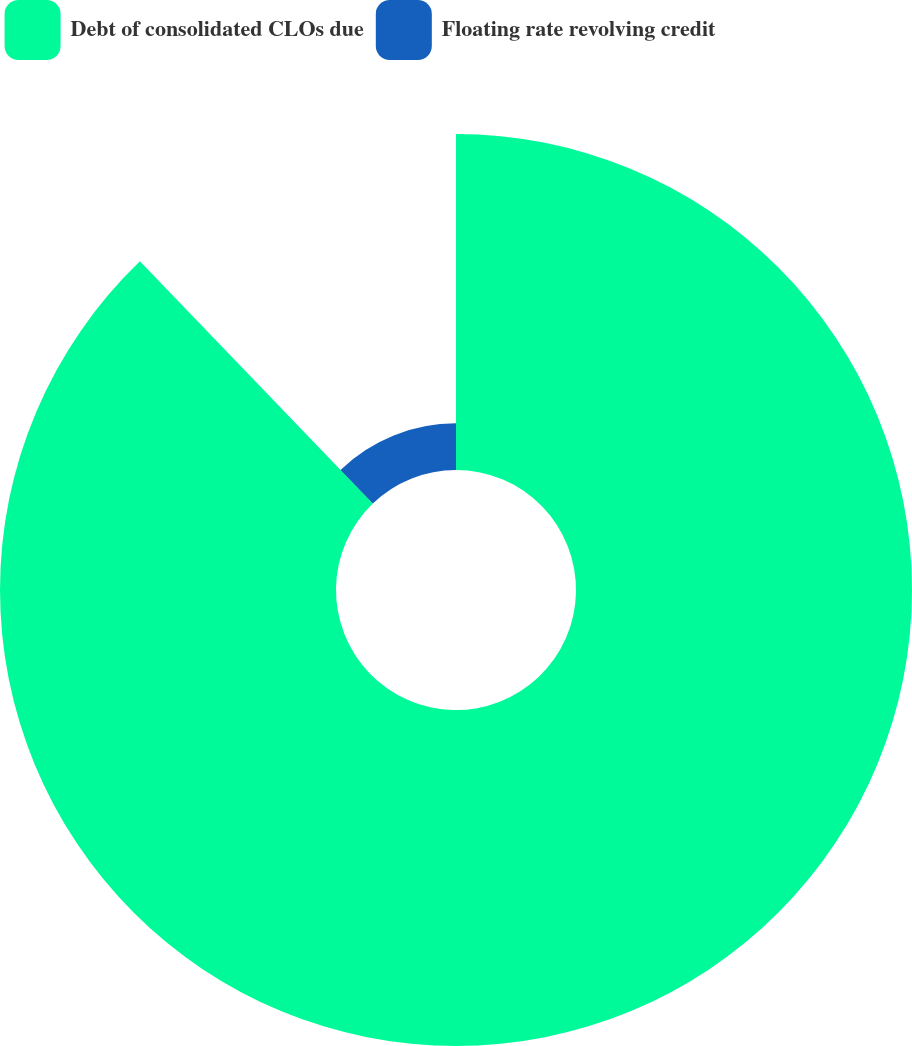Convert chart. <chart><loc_0><loc_0><loc_500><loc_500><pie_chart><fcel>Debt of consolidated CLOs due<fcel>Floating rate revolving credit<nl><fcel>87.81%<fcel>12.19%<nl></chart> 